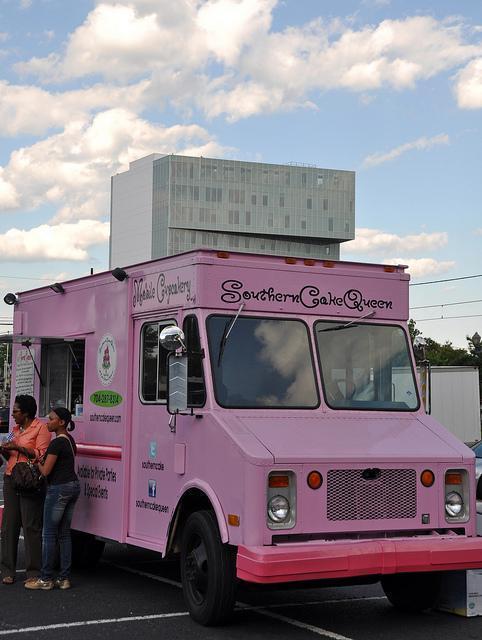If this truck sold food the same color that the truck is what food would it sell?
Select the accurate response from the four choices given to answer the question.
Options: Blueberry, watermelon, peas, carrot. Watermelon. 